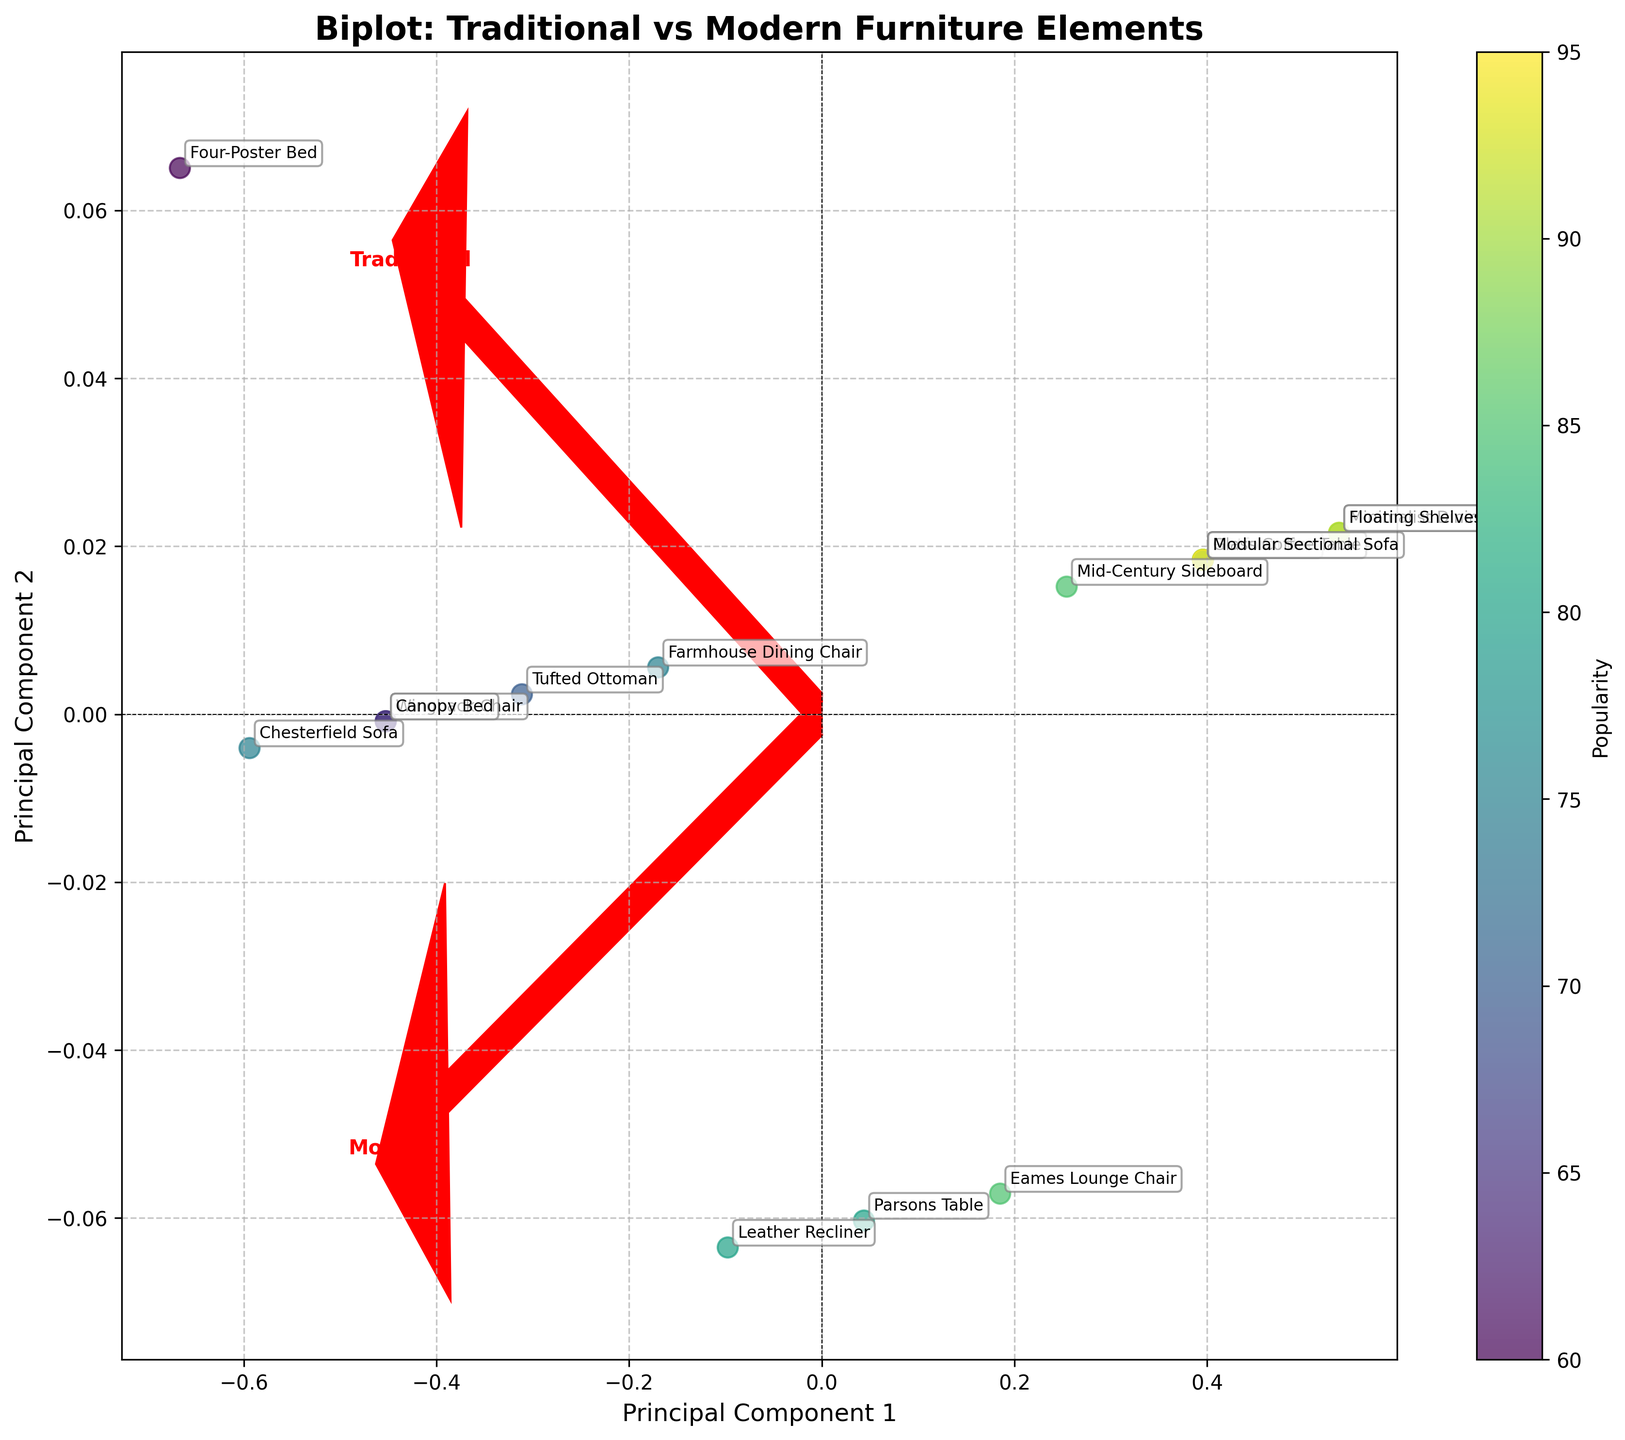Which furniture style has the highest popularity score? To find the furniture style with the highest popularity score, look at the color bar representing popularity and identify the data point with the brightest color.
Answer: Minimalist Dining Table Which axes represent the traditional and modern elements? Traditional and modern elements are represented by the direction of the red arrows labeled "Traditional" and "Modern" respectively. Traditional elements are on the horizontal axis, while modern elements are on the vertical axis.
Answer: Horizontal: Traditional, Vertical: Modern How many furniture styles fall closer to the modern element vector than to the traditional element vector? Look at the projection of each furniture style relative to the direction of the "Modern" vector. If a furniture style is closer to the "Modern" vector than the "Traditional" vector, it indicates a stronger modern component. Count these data points.
Answer: 8 styles Which furniture style is most closely aligned with traditional elements? Locate the furniture style closest to the arrow labeled "Traditional." This style is most aligned with traditional elements.
Answer: Chesterfield Sofa Are there any furniture styles that score equally on traditional and modern elements? Identify the data points located diagonally between the two vectors, which indicates equal strength in both traditional and modern elements.
Answer: Leather Recliner What is the relationship between popularity and the alignment with traditional or modern elements? Compare the colors of the data points on different sides of the plot. The popularity is higher for styles aligning with the "Modern" vector (brighter colors) and lower for those aligning with the "Traditional" vector (darker colors).
Answer: Modern elements tend to be more popular Which furniture style is an outlier in terms of having a high modern element score but a moderate popularity score? Look for data points near the "Modern" vector with a relatively dim color compared to others around it.
Answer: Glass Coffee Table Are there any clusters of furniture styles based on their element composition? Observe the plot for groups of data points that are close together. Clusters indicate similar compositions of traditional and modern elements.
Answer: Yes, there's a cluster around the Modern vector Which furniture style has the lowest sustainability score and what is its alignment? Identify the least sustainable furniture style by finding the least colorful (dim colored) data point based on sustainability and noting its position relative to the vectors.
Answer: Four-Poster Bed, aligned more with Traditional elements Which furniture styles show a significant balance between traditional and modern elements? Identify the data points that fall in the region where the traditional and modern vectors intersect or in closer proximity to both vectors equally.
Answer: Leather Recliner, Farmhouse Dining Chair 